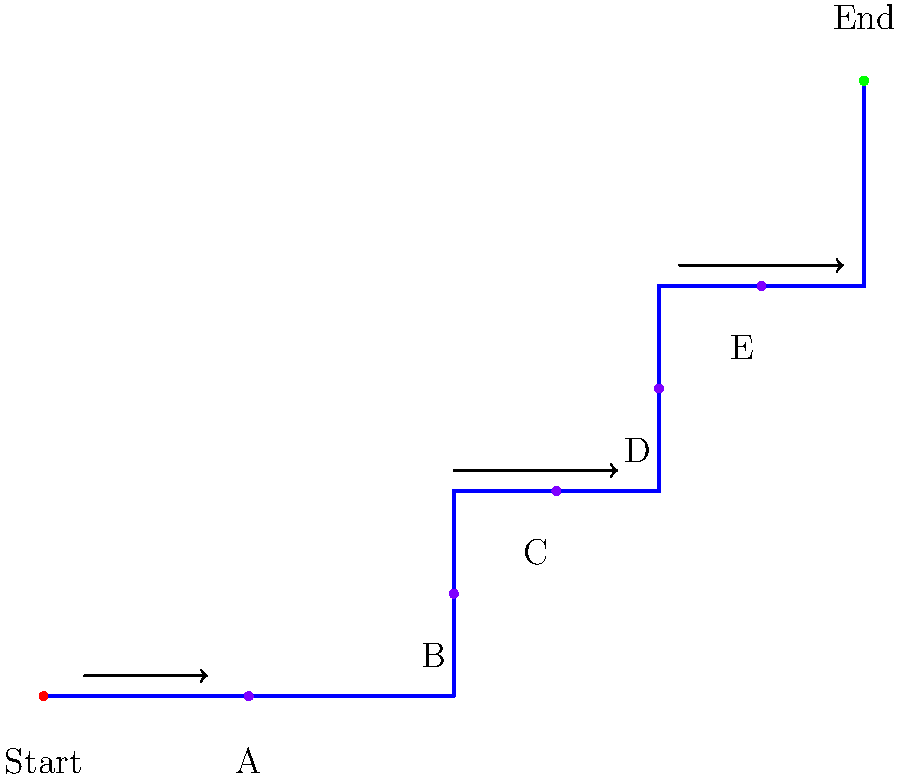Analyze the top-down view of this game level. Which sequence of key elements (A, B, C, D, E) would create the most effective player flow, considering the principles of level design and pacing? To determine the most effective player flow, we need to consider several principles of level design:

1. Progression: The level should guide the player from start to finish in a logical manner.
2. Pacing: The placement of key elements should create a rhythm of tension and release.
3. Challenge escalation: Difficulty should increase gradually as the player progresses.
4. Exploration: The layout should encourage some exploration without causing confusion.

Analyzing the map:
1. The main path (blue line) suggests a general direction from bottom-left to top-right.
2. Key elements A, B, C, D, and E are placed along or near this path.
3. The spacing between elements increases as we move towards the end, potentially indicating increasing complexity or challenge.

Considering these factors, the most effective sequence would be:

A -> B -> C -> D -> E

Reasons:
1. This sequence follows the natural progression of the level layout.
2. It provides a steady increase in spacing between elements, allowing for gradual difficulty increase and moments of rest between challenges.
3. The slight deviations from the main path (e.g., B and D) encourage exploration without straying too far from the intended route.
4. The final element (E) is placed closer to the end, potentially serving as a final challenge or reward before reaching the goal.

This sequence would create a smooth flow, balancing guidance and exploration while maintaining an engaging pace and gradually increasing challenge.
Answer: A -> B -> C -> D -> E 